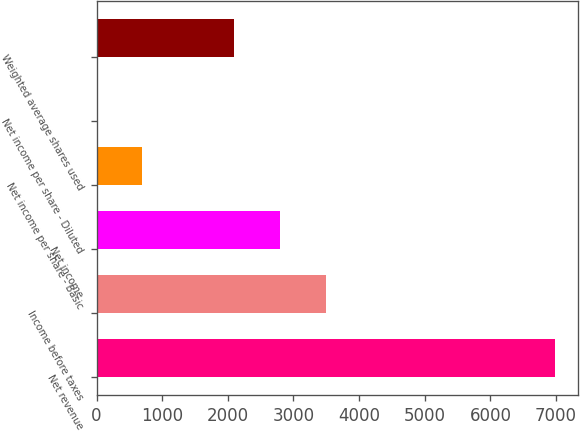Convert chart. <chart><loc_0><loc_0><loc_500><loc_500><bar_chart><fcel>Net revenue<fcel>Income before taxes<fcel>Net income<fcel>Net income per share - Basic<fcel>Net income per share - Diluted<fcel>Weighted average shares used<nl><fcel>6981<fcel>3491.24<fcel>2793.29<fcel>699.44<fcel>1.49<fcel>2095.34<nl></chart> 